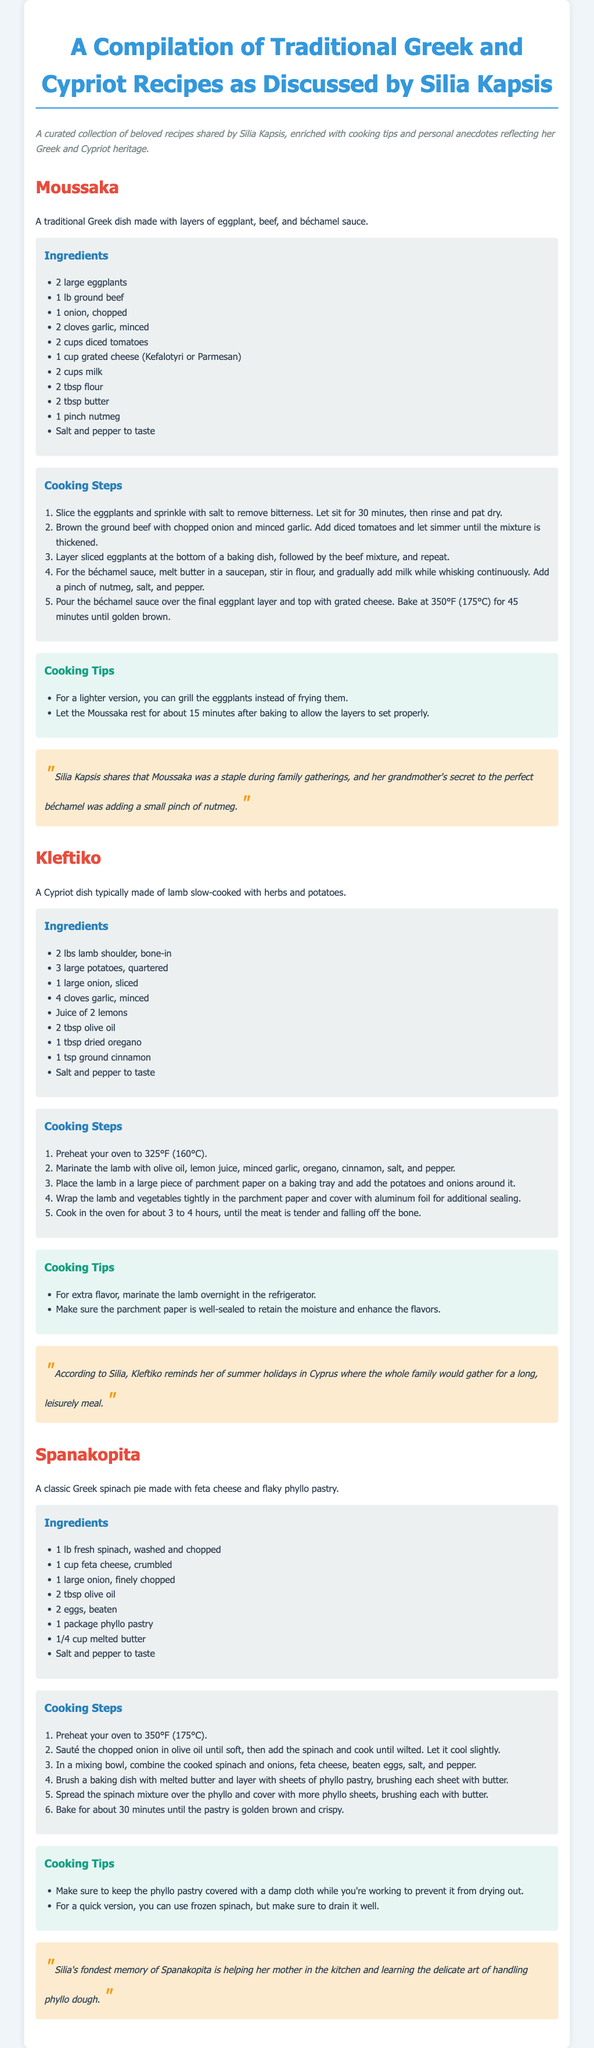What is the main dish featured in the document? The main dish is identified in the title for each section of recipes, with "Moussaka" being the first listed.
Answer: Moussaka How many ingredients are listed for Kleftiko? The ingredients section for Kleftiko contains a bullet list where eight items are enumerated.
Answer: 8 What is the oven temperature for baking Spanakopita? The cooking steps for Spanakopita recommend preheating the oven to a specific temperature, which is mentioned in the instructions.
Answer: 350°F (175°C) What cooking method is suggested for a lighter version of Moussaka? The cooking tips for Moussaka explicitly suggest an alternative method for preparing the eggplants.
Answer: Grill In which location does Silia Kapsis associate her fondest memories of Kleftiko? The anecdote for Kleftiko refers to specific summer experiences that Silia recalls, indicating the setting of these memories.
Answer: Cyprus What ingredient is mentioned as a secret to the perfect béchamel sauce? The anecdote for Moussaka shares this detail about her grandmother's cooking.
Answer: Nutmeg How long should Moussaka rest after baking? The tips section for Moussaka specifically states the resting time after it is baked to ensure the layers set properly.
Answer: 15 minutes Which cheese is typically used in Spanakopita? The ingredients list for Spanakopita identifies a specific cheese used in the recipe.
Answer: Feta cheese 